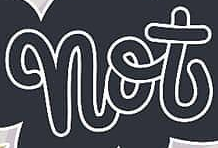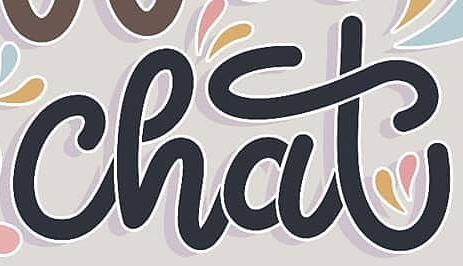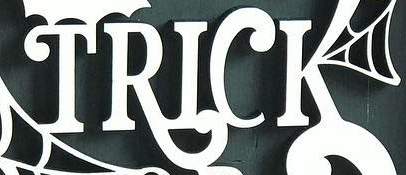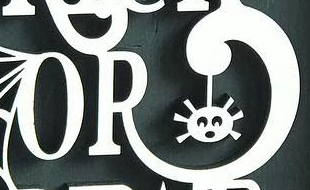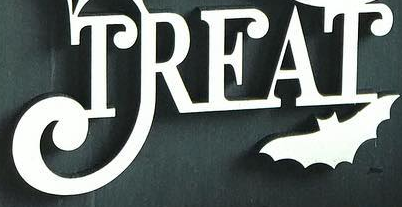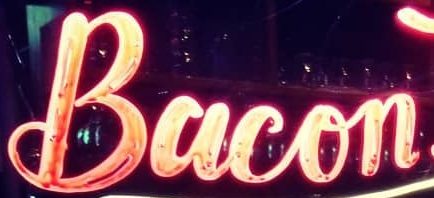What text is displayed in these images sequentially, separated by a semicolon? not; chat; TRICK; OR; TREAT; Bacon 